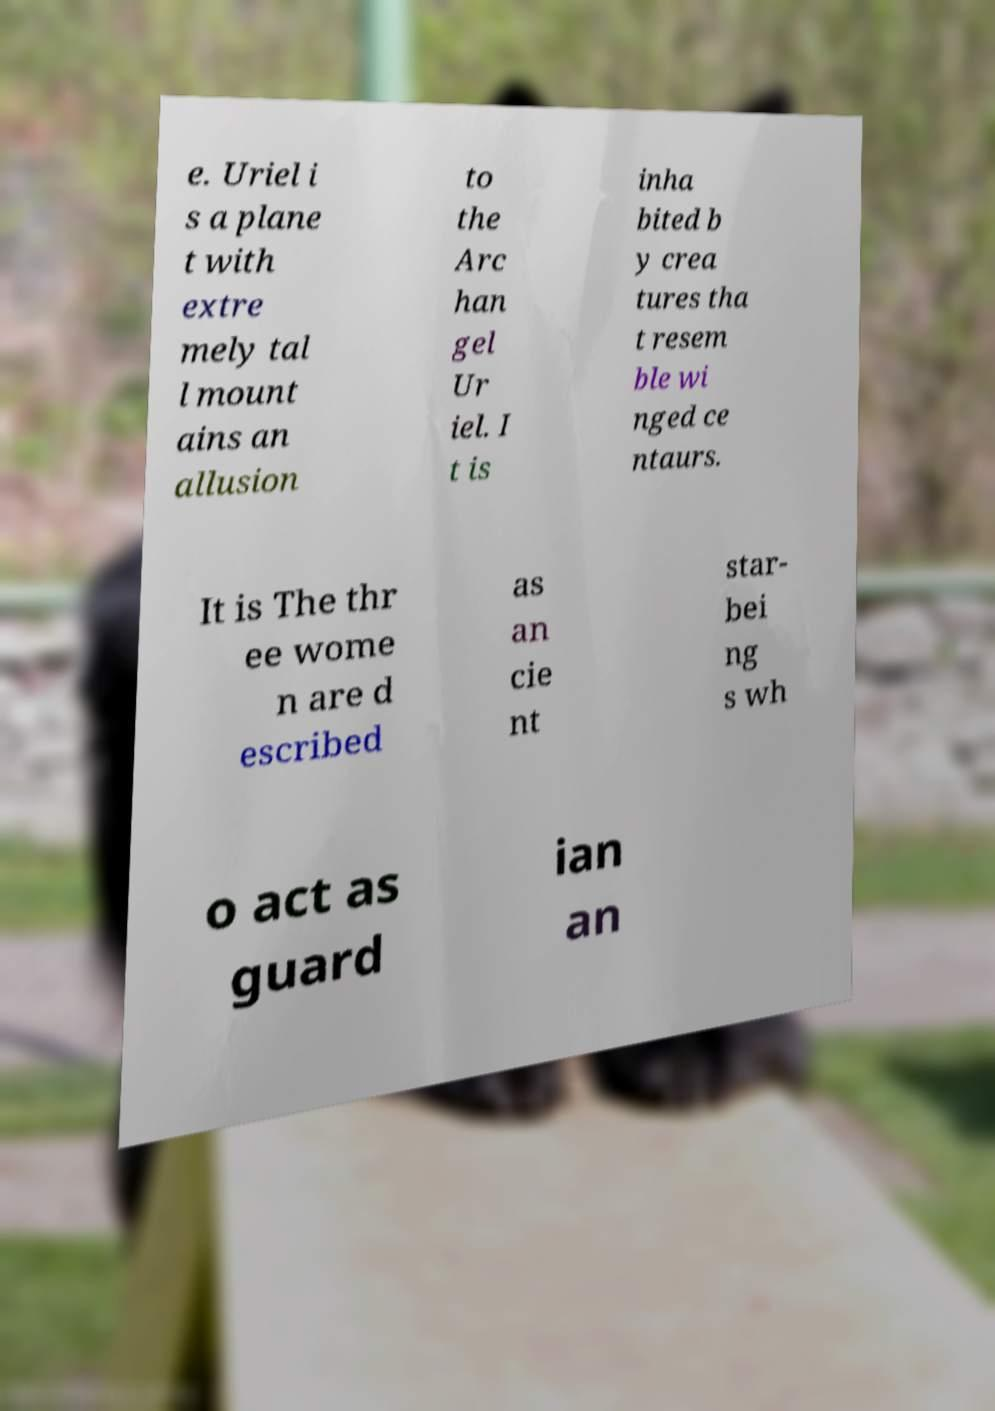What messages or text are displayed in this image? I need them in a readable, typed format. e. Uriel i s a plane t with extre mely tal l mount ains an allusion to the Arc han gel Ur iel. I t is inha bited b y crea tures tha t resem ble wi nged ce ntaurs. It is The thr ee wome n are d escribed as an cie nt star- bei ng s wh o act as guard ian an 